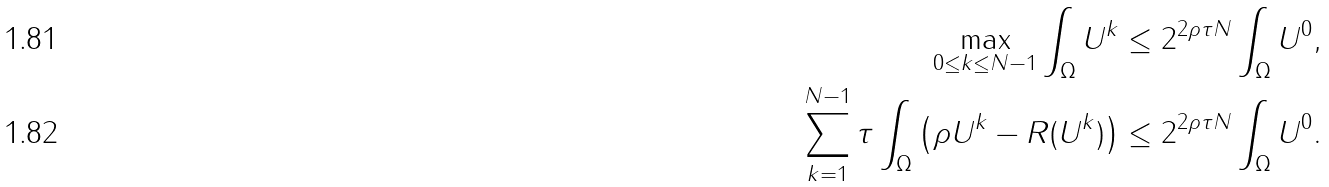Convert formula to latex. <formula><loc_0><loc_0><loc_500><loc_500>\max _ { 0 \leq k \leq N - 1 } \int _ { \Omega } U ^ { k } & \leq 2 ^ { 2 \rho \tau N } \int _ { \Omega } U ^ { 0 } , \\ \sum _ { k = 1 } ^ { N - 1 } \tau \int _ { \Omega } \left ( \rho U ^ { k } - R ( U ^ { k } ) \right ) & \leq 2 ^ { 2 \rho \tau N } \int _ { \Omega } U ^ { 0 } .</formula> 